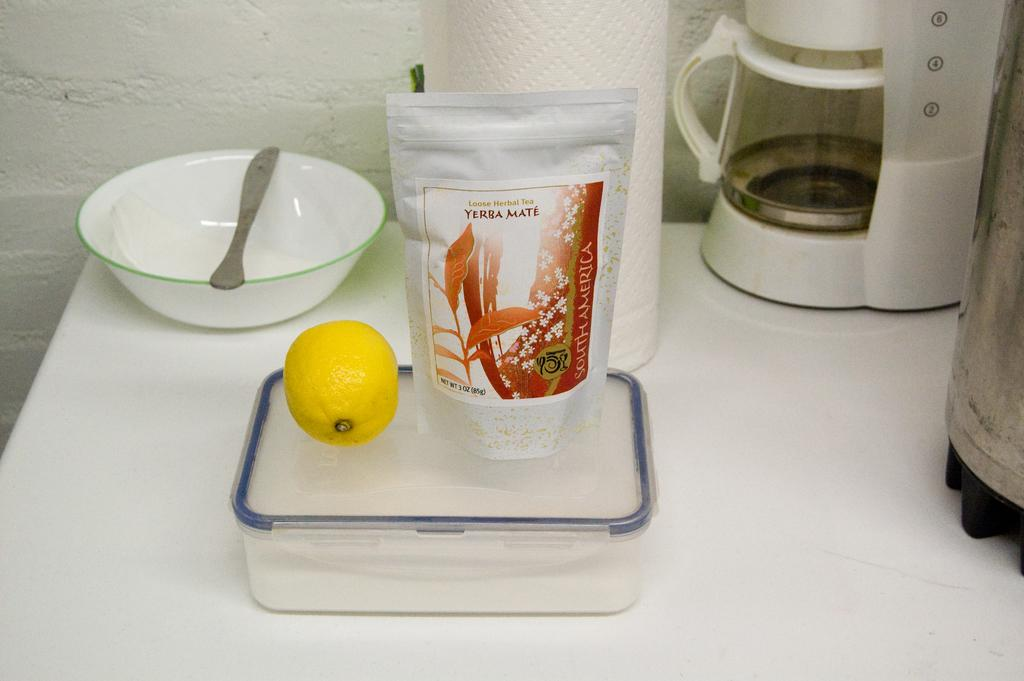<image>
Create a compact narrative representing the image presented. A bag of yerba mate tea leaves sits on a plastic box on a counter top along with a whole lemon. 